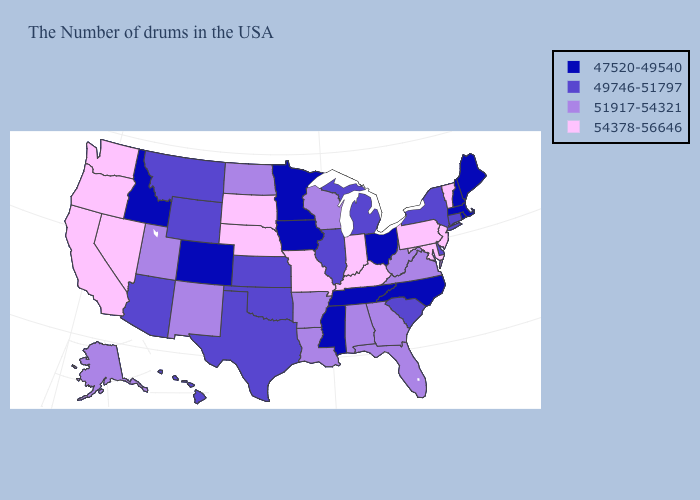Does Tennessee have the same value as Rhode Island?
Give a very brief answer. Yes. Which states hav the highest value in the West?
Answer briefly. Nevada, California, Washington, Oregon. Name the states that have a value in the range 54378-56646?
Keep it brief. Vermont, New Jersey, Maryland, Pennsylvania, Kentucky, Indiana, Missouri, Nebraska, South Dakota, Nevada, California, Washington, Oregon. Name the states that have a value in the range 54378-56646?
Answer briefly. Vermont, New Jersey, Maryland, Pennsylvania, Kentucky, Indiana, Missouri, Nebraska, South Dakota, Nevada, California, Washington, Oregon. Name the states that have a value in the range 47520-49540?
Give a very brief answer. Maine, Massachusetts, Rhode Island, New Hampshire, North Carolina, Ohio, Tennessee, Mississippi, Minnesota, Iowa, Colorado, Idaho. Name the states that have a value in the range 51917-54321?
Write a very short answer. Virginia, West Virginia, Florida, Georgia, Alabama, Wisconsin, Louisiana, Arkansas, North Dakota, New Mexico, Utah, Alaska. Name the states that have a value in the range 47520-49540?
Quick response, please. Maine, Massachusetts, Rhode Island, New Hampshire, North Carolina, Ohio, Tennessee, Mississippi, Minnesota, Iowa, Colorado, Idaho. Among the states that border Kentucky , does Indiana have the highest value?
Keep it brief. Yes. Name the states that have a value in the range 54378-56646?
Quick response, please. Vermont, New Jersey, Maryland, Pennsylvania, Kentucky, Indiana, Missouri, Nebraska, South Dakota, Nevada, California, Washington, Oregon. What is the value of South Dakota?
Concise answer only. 54378-56646. Which states have the lowest value in the Northeast?
Give a very brief answer. Maine, Massachusetts, Rhode Island, New Hampshire. Among the states that border Wyoming , which have the highest value?
Quick response, please. Nebraska, South Dakota. What is the value of New Mexico?
Keep it brief. 51917-54321. Name the states that have a value in the range 51917-54321?
Be succinct. Virginia, West Virginia, Florida, Georgia, Alabama, Wisconsin, Louisiana, Arkansas, North Dakota, New Mexico, Utah, Alaska. 